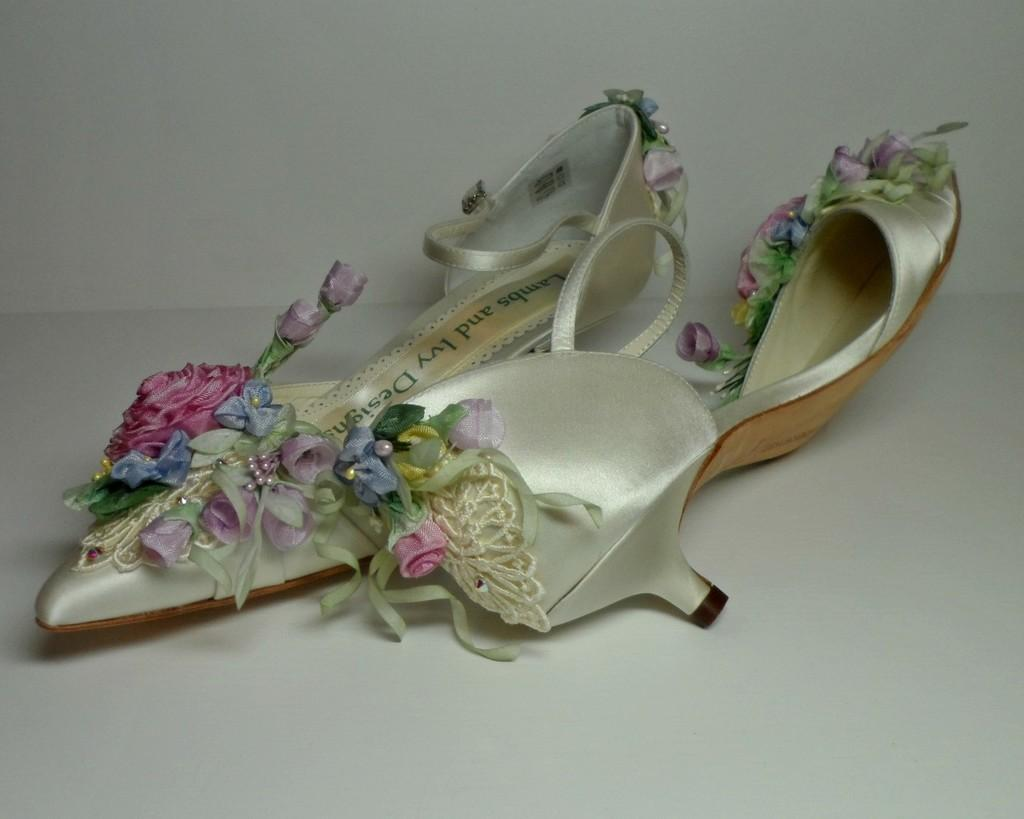What is the main subject in the center of the image? There is footwear in the center of the image. What color is the background of the image? The background of the image is white. What type of surface is visible at the bottom of the image? There is a floor visible at the bottom of the image. Can you tell me how many spies are hiding behind the footwear in the image? There are no spies present in the image; it only features footwear and a white background. What type of rabbit can be seen hopping on the floor in the image? There is no rabbit present in the image; it only features footwear and a white background. 